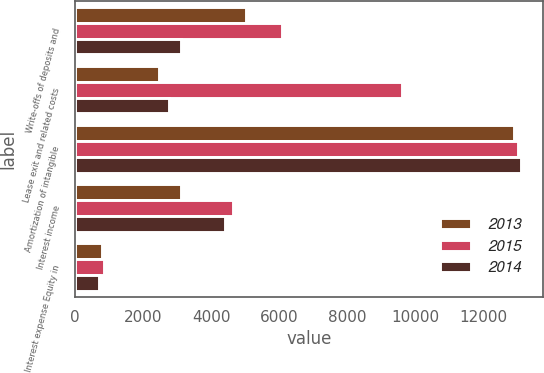Convert chart to OTSL. <chart><loc_0><loc_0><loc_500><loc_500><stacked_bar_chart><ecel><fcel>Write-offs of deposits and<fcel>Lease exit and related costs<fcel>Amortization of intangible<fcel>Interest income<fcel>Interest expense Equity in<nl><fcel>2013<fcel>5021<fcel>2463<fcel>12900<fcel>3107<fcel>788<nl><fcel>2015<fcel>6099<fcel>9609<fcel>13033<fcel>4632<fcel>849<nl><fcel>2014<fcel>3122<fcel>2778<fcel>13100<fcel>4395<fcel>712<nl></chart> 